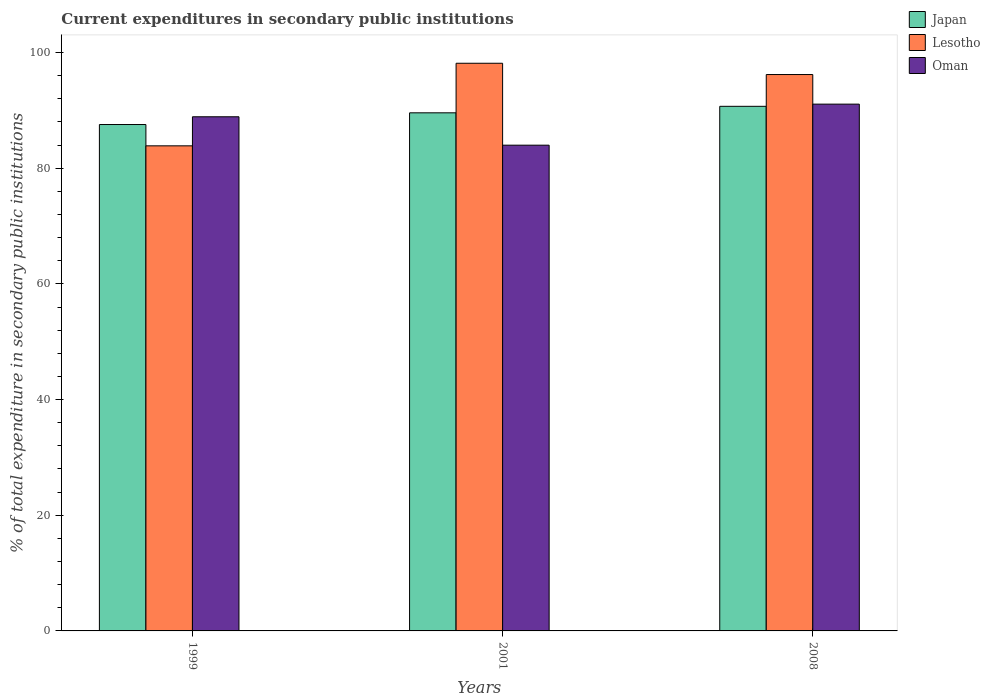Are the number of bars per tick equal to the number of legend labels?
Keep it short and to the point. Yes. Are the number of bars on each tick of the X-axis equal?
Offer a very short reply. Yes. How many bars are there on the 1st tick from the right?
Offer a very short reply. 3. What is the current expenditures in secondary public institutions in Lesotho in 2008?
Ensure brevity in your answer.  96.2. Across all years, what is the maximum current expenditures in secondary public institutions in Oman?
Ensure brevity in your answer.  91.08. Across all years, what is the minimum current expenditures in secondary public institutions in Japan?
Your answer should be compact. 87.56. In which year was the current expenditures in secondary public institutions in Lesotho maximum?
Make the answer very short. 2001. What is the total current expenditures in secondary public institutions in Oman in the graph?
Provide a succinct answer. 263.97. What is the difference between the current expenditures in secondary public institutions in Lesotho in 1999 and that in 2001?
Offer a terse response. -14.28. What is the difference between the current expenditures in secondary public institutions in Lesotho in 2008 and the current expenditures in secondary public institutions in Oman in 2001?
Your answer should be very brief. 12.21. What is the average current expenditures in secondary public institutions in Oman per year?
Offer a very short reply. 87.99. In the year 2001, what is the difference between the current expenditures in secondary public institutions in Oman and current expenditures in secondary public institutions in Lesotho?
Provide a short and direct response. -14.16. In how many years, is the current expenditures in secondary public institutions in Oman greater than 80 %?
Keep it short and to the point. 3. What is the ratio of the current expenditures in secondary public institutions in Japan in 1999 to that in 2008?
Offer a very short reply. 0.97. Is the difference between the current expenditures in secondary public institutions in Oman in 2001 and 2008 greater than the difference between the current expenditures in secondary public institutions in Lesotho in 2001 and 2008?
Keep it short and to the point. No. What is the difference between the highest and the second highest current expenditures in secondary public institutions in Lesotho?
Keep it short and to the point. 1.95. What is the difference between the highest and the lowest current expenditures in secondary public institutions in Lesotho?
Make the answer very short. 14.28. Is the sum of the current expenditures in secondary public institutions in Oman in 2001 and 2008 greater than the maximum current expenditures in secondary public institutions in Japan across all years?
Your response must be concise. Yes. What does the 2nd bar from the left in 2001 represents?
Ensure brevity in your answer.  Lesotho. What does the 1st bar from the right in 2008 represents?
Your answer should be very brief. Oman. Is it the case that in every year, the sum of the current expenditures in secondary public institutions in Lesotho and current expenditures in secondary public institutions in Japan is greater than the current expenditures in secondary public institutions in Oman?
Make the answer very short. Yes. How many bars are there?
Keep it short and to the point. 9. Are the values on the major ticks of Y-axis written in scientific E-notation?
Offer a very short reply. No. How many legend labels are there?
Offer a terse response. 3. What is the title of the graph?
Your answer should be very brief. Current expenditures in secondary public institutions. Does "Dominica" appear as one of the legend labels in the graph?
Provide a succinct answer. No. What is the label or title of the Y-axis?
Give a very brief answer. % of total expenditure in secondary public institutions. What is the % of total expenditure in secondary public institutions of Japan in 1999?
Your response must be concise. 87.56. What is the % of total expenditure in secondary public institutions of Lesotho in 1999?
Provide a succinct answer. 83.87. What is the % of total expenditure in secondary public institutions in Oman in 1999?
Provide a short and direct response. 88.9. What is the % of total expenditure in secondary public institutions of Japan in 2001?
Keep it short and to the point. 89.58. What is the % of total expenditure in secondary public institutions of Lesotho in 2001?
Provide a short and direct response. 98.15. What is the % of total expenditure in secondary public institutions in Oman in 2001?
Keep it short and to the point. 83.99. What is the % of total expenditure in secondary public institutions of Japan in 2008?
Provide a succinct answer. 90.7. What is the % of total expenditure in secondary public institutions of Lesotho in 2008?
Provide a short and direct response. 96.2. What is the % of total expenditure in secondary public institutions in Oman in 2008?
Make the answer very short. 91.08. Across all years, what is the maximum % of total expenditure in secondary public institutions of Japan?
Offer a terse response. 90.7. Across all years, what is the maximum % of total expenditure in secondary public institutions of Lesotho?
Offer a very short reply. 98.15. Across all years, what is the maximum % of total expenditure in secondary public institutions in Oman?
Keep it short and to the point. 91.08. Across all years, what is the minimum % of total expenditure in secondary public institutions in Japan?
Your answer should be very brief. 87.56. Across all years, what is the minimum % of total expenditure in secondary public institutions of Lesotho?
Your response must be concise. 83.87. Across all years, what is the minimum % of total expenditure in secondary public institutions of Oman?
Offer a terse response. 83.99. What is the total % of total expenditure in secondary public institutions in Japan in the graph?
Your answer should be compact. 267.84. What is the total % of total expenditure in secondary public institutions of Lesotho in the graph?
Keep it short and to the point. 278.22. What is the total % of total expenditure in secondary public institutions in Oman in the graph?
Make the answer very short. 263.97. What is the difference between the % of total expenditure in secondary public institutions of Japan in 1999 and that in 2001?
Offer a very short reply. -2.02. What is the difference between the % of total expenditure in secondary public institutions of Lesotho in 1999 and that in 2001?
Your answer should be compact. -14.28. What is the difference between the % of total expenditure in secondary public institutions in Oman in 1999 and that in 2001?
Provide a short and direct response. 4.91. What is the difference between the % of total expenditure in secondary public institutions in Japan in 1999 and that in 2008?
Offer a terse response. -3.15. What is the difference between the % of total expenditure in secondary public institutions of Lesotho in 1999 and that in 2008?
Make the answer very short. -12.33. What is the difference between the % of total expenditure in secondary public institutions of Oman in 1999 and that in 2008?
Offer a terse response. -2.18. What is the difference between the % of total expenditure in secondary public institutions of Japan in 2001 and that in 2008?
Your answer should be compact. -1.12. What is the difference between the % of total expenditure in secondary public institutions in Lesotho in 2001 and that in 2008?
Offer a terse response. 1.95. What is the difference between the % of total expenditure in secondary public institutions of Oman in 2001 and that in 2008?
Offer a terse response. -7.1. What is the difference between the % of total expenditure in secondary public institutions in Japan in 1999 and the % of total expenditure in secondary public institutions in Lesotho in 2001?
Provide a succinct answer. -10.59. What is the difference between the % of total expenditure in secondary public institutions in Japan in 1999 and the % of total expenditure in secondary public institutions in Oman in 2001?
Give a very brief answer. 3.57. What is the difference between the % of total expenditure in secondary public institutions in Lesotho in 1999 and the % of total expenditure in secondary public institutions in Oman in 2001?
Provide a succinct answer. -0.12. What is the difference between the % of total expenditure in secondary public institutions of Japan in 1999 and the % of total expenditure in secondary public institutions of Lesotho in 2008?
Your response must be concise. -8.64. What is the difference between the % of total expenditure in secondary public institutions in Japan in 1999 and the % of total expenditure in secondary public institutions in Oman in 2008?
Provide a succinct answer. -3.53. What is the difference between the % of total expenditure in secondary public institutions in Lesotho in 1999 and the % of total expenditure in secondary public institutions in Oman in 2008?
Provide a short and direct response. -7.21. What is the difference between the % of total expenditure in secondary public institutions of Japan in 2001 and the % of total expenditure in secondary public institutions of Lesotho in 2008?
Your response must be concise. -6.62. What is the difference between the % of total expenditure in secondary public institutions of Japan in 2001 and the % of total expenditure in secondary public institutions of Oman in 2008?
Provide a short and direct response. -1.5. What is the difference between the % of total expenditure in secondary public institutions in Lesotho in 2001 and the % of total expenditure in secondary public institutions in Oman in 2008?
Offer a very short reply. 7.07. What is the average % of total expenditure in secondary public institutions of Japan per year?
Your answer should be very brief. 89.28. What is the average % of total expenditure in secondary public institutions of Lesotho per year?
Ensure brevity in your answer.  92.74. What is the average % of total expenditure in secondary public institutions of Oman per year?
Offer a terse response. 87.99. In the year 1999, what is the difference between the % of total expenditure in secondary public institutions in Japan and % of total expenditure in secondary public institutions in Lesotho?
Your response must be concise. 3.69. In the year 1999, what is the difference between the % of total expenditure in secondary public institutions in Japan and % of total expenditure in secondary public institutions in Oman?
Offer a terse response. -1.34. In the year 1999, what is the difference between the % of total expenditure in secondary public institutions in Lesotho and % of total expenditure in secondary public institutions in Oman?
Provide a short and direct response. -5.03. In the year 2001, what is the difference between the % of total expenditure in secondary public institutions in Japan and % of total expenditure in secondary public institutions in Lesotho?
Give a very brief answer. -8.57. In the year 2001, what is the difference between the % of total expenditure in secondary public institutions of Japan and % of total expenditure in secondary public institutions of Oman?
Your response must be concise. 5.59. In the year 2001, what is the difference between the % of total expenditure in secondary public institutions in Lesotho and % of total expenditure in secondary public institutions in Oman?
Make the answer very short. 14.16. In the year 2008, what is the difference between the % of total expenditure in secondary public institutions in Japan and % of total expenditure in secondary public institutions in Lesotho?
Your answer should be very brief. -5.5. In the year 2008, what is the difference between the % of total expenditure in secondary public institutions in Japan and % of total expenditure in secondary public institutions in Oman?
Offer a terse response. -0.38. In the year 2008, what is the difference between the % of total expenditure in secondary public institutions of Lesotho and % of total expenditure in secondary public institutions of Oman?
Provide a succinct answer. 5.12. What is the ratio of the % of total expenditure in secondary public institutions of Japan in 1999 to that in 2001?
Keep it short and to the point. 0.98. What is the ratio of the % of total expenditure in secondary public institutions in Lesotho in 1999 to that in 2001?
Make the answer very short. 0.85. What is the ratio of the % of total expenditure in secondary public institutions in Oman in 1999 to that in 2001?
Offer a very short reply. 1.06. What is the ratio of the % of total expenditure in secondary public institutions in Japan in 1999 to that in 2008?
Make the answer very short. 0.97. What is the ratio of the % of total expenditure in secondary public institutions of Lesotho in 1999 to that in 2008?
Offer a terse response. 0.87. What is the ratio of the % of total expenditure in secondary public institutions in Japan in 2001 to that in 2008?
Provide a short and direct response. 0.99. What is the ratio of the % of total expenditure in secondary public institutions in Lesotho in 2001 to that in 2008?
Make the answer very short. 1.02. What is the ratio of the % of total expenditure in secondary public institutions of Oman in 2001 to that in 2008?
Give a very brief answer. 0.92. What is the difference between the highest and the second highest % of total expenditure in secondary public institutions of Japan?
Offer a very short reply. 1.12. What is the difference between the highest and the second highest % of total expenditure in secondary public institutions of Lesotho?
Make the answer very short. 1.95. What is the difference between the highest and the second highest % of total expenditure in secondary public institutions of Oman?
Offer a very short reply. 2.18. What is the difference between the highest and the lowest % of total expenditure in secondary public institutions in Japan?
Provide a short and direct response. 3.15. What is the difference between the highest and the lowest % of total expenditure in secondary public institutions in Lesotho?
Give a very brief answer. 14.28. What is the difference between the highest and the lowest % of total expenditure in secondary public institutions of Oman?
Make the answer very short. 7.1. 